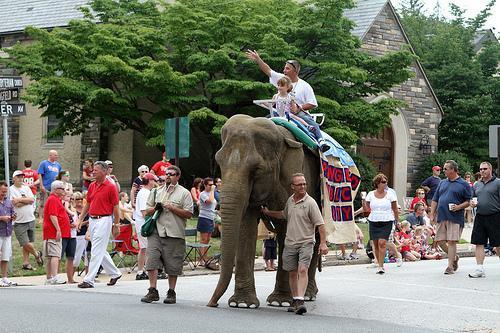How many elephants are there?
Give a very brief answer. 1. 